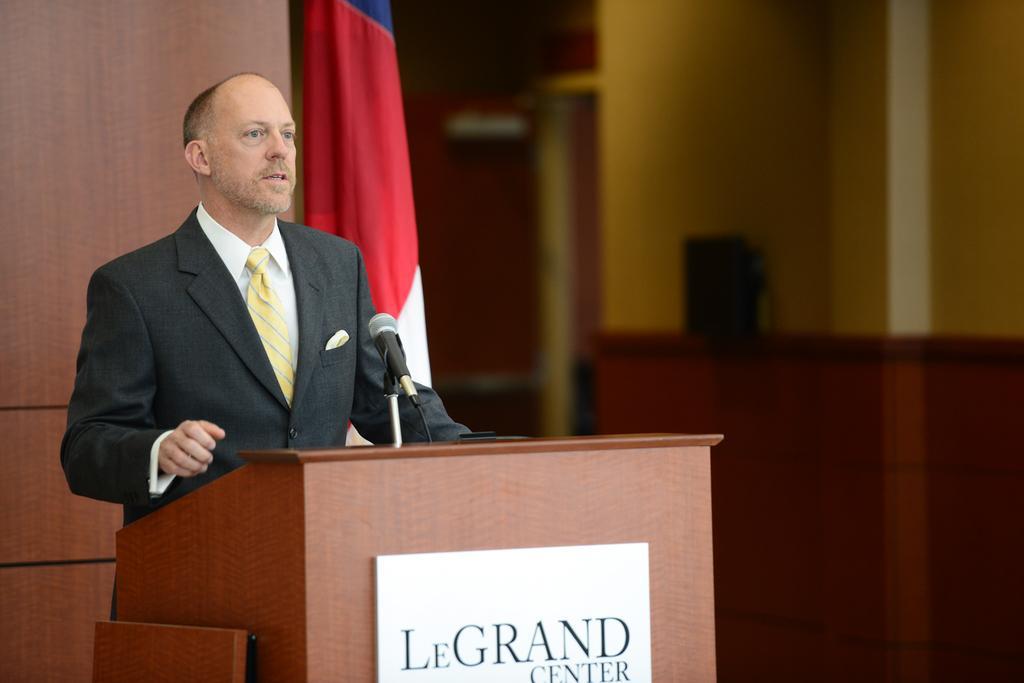How would you summarize this image in a sentence or two? In this picture we can see the man wearing a black suit, standing at the wooden speech desk and giving a speech. Behind there is a wooden panel wall. In the background we can see the yellow wall. 